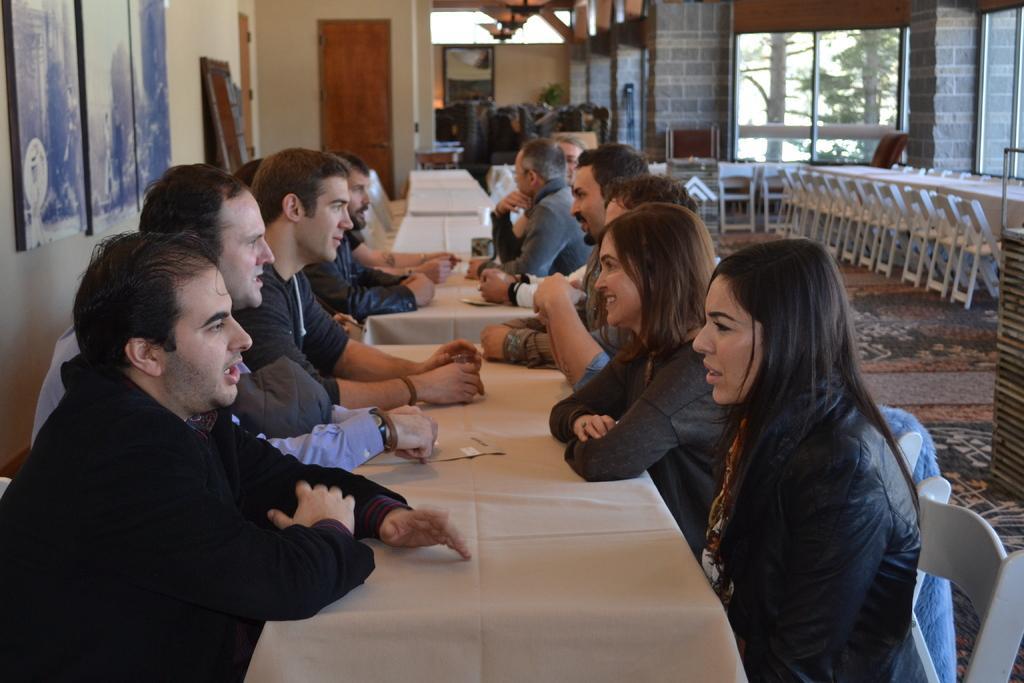Please provide a concise description of this image. In this image we can see few people are sitting near the table. We can see photo frames on the wall. In the background we can see glass windows through which 